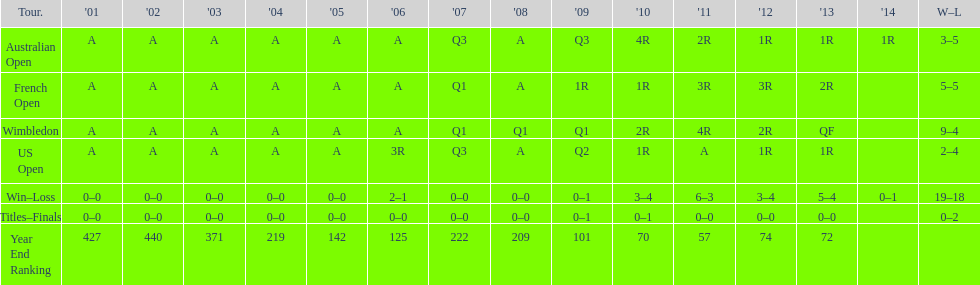In what year was the best year end ranking achieved? 2011. 